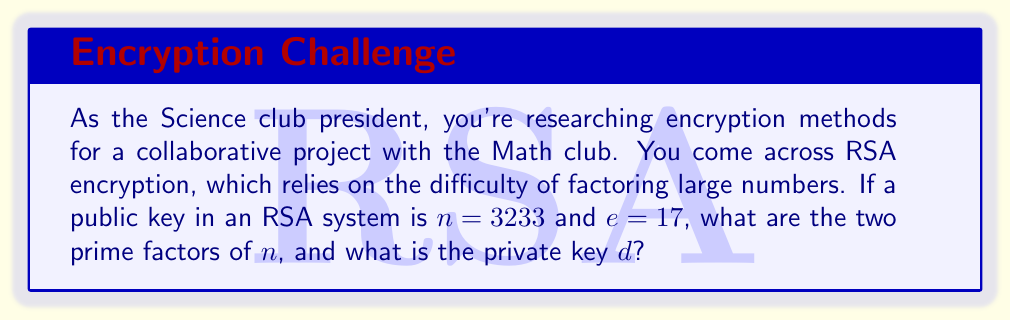Could you help me with this problem? To solve this problem, we need to follow these steps:

1) First, we need to find the prime factors of $n = 3233$. This is the crucial step in breaking RSA encryption. We can use trial division:

   $3233 = 61 \times 53$

2) Now that we have the prime factors $p = 61$ and $q = 53$, we can calculate $\phi(n)$:

   $\phi(n) = (p-1)(q-1) = 60 \times 52 = 3120$

3) To find the private key $d$, we need to solve the congruence:

   $ed \equiv 1 \pmod{\phi(n)}$

   Or: $17d \equiv 1 \pmod{3120}$

4) We can use the extended Euclidean algorithm to find $d$:

   $3120 = 183 \times 17 + 9$
   $17 = 1 \times 9 + 8$
   $9 = 1 \times 8 + 1$

   Working backwards:
   $1 = 9 - 1 \times 8$
   $1 = 9 - 1 \times (17 - 1 \times 9) = 2 \times 9 - 1 \times 17$
   $1 = 2 \times (3120 - 183 \times 17) - 1 \times 17$
   $1 = 2 \times 3120 - 367 \times 17$

5) Therefore, $d \equiv -367 \pmod{3120}$, or $d \equiv 2753 \pmod{3120}$

This process demonstrates how prime factorization is fundamental to the security of RSA encryption, as knowing the factors allows for the calculation of the private key.
Answer: The prime factors of $n$ are 61 and 53. The private key $d$ is 2753. 